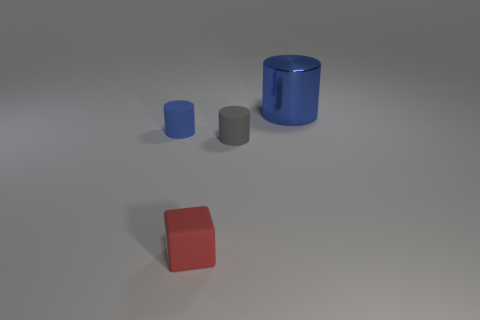There is a cylinder that is behind the blue cylinder in front of the big metal cylinder; what number of small gray matte cylinders are behind it?
Offer a very short reply. 0. There is a thing that is the same color as the large shiny cylinder; what is its material?
Offer a terse response. Rubber. Is there any other thing that has the same shape as the blue metal thing?
Ensure brevity in your answer.  Yes. What number of things are either rubber objects that are left of the tiny red thing or blue metal cylinders?
Your answer should be compact. 2. Does the rubber object that is in front of the small gray matte cylinder have the same color as the large cylinder?
Provide a short and direct response. No. What is the shape of the object that is on the right side of the small cylinder that is right of the red matte block?
Your answer should be compact. Cylinder. Are there fewer red cubes that are on the right side of the large blue cylinder than red cubes to the left of the tiny red rubber cube?
Your response must be concise. No. What size is the blue metal thing that is the same shape as the gray matte thing?
Provide a succinct answer. Large. Is there any other thing that has the same size as the red cube?
Offer a terse response. Yes. What number of things are either rubber cylinders on the left side of the tiny red matte cube or blue cylinders that are in front of the big metallic cylinder?
Your answer should be compact. 1. 